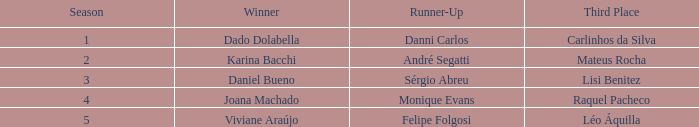How many contestants were there when the runner-up was Monique Evans? 15.0. 